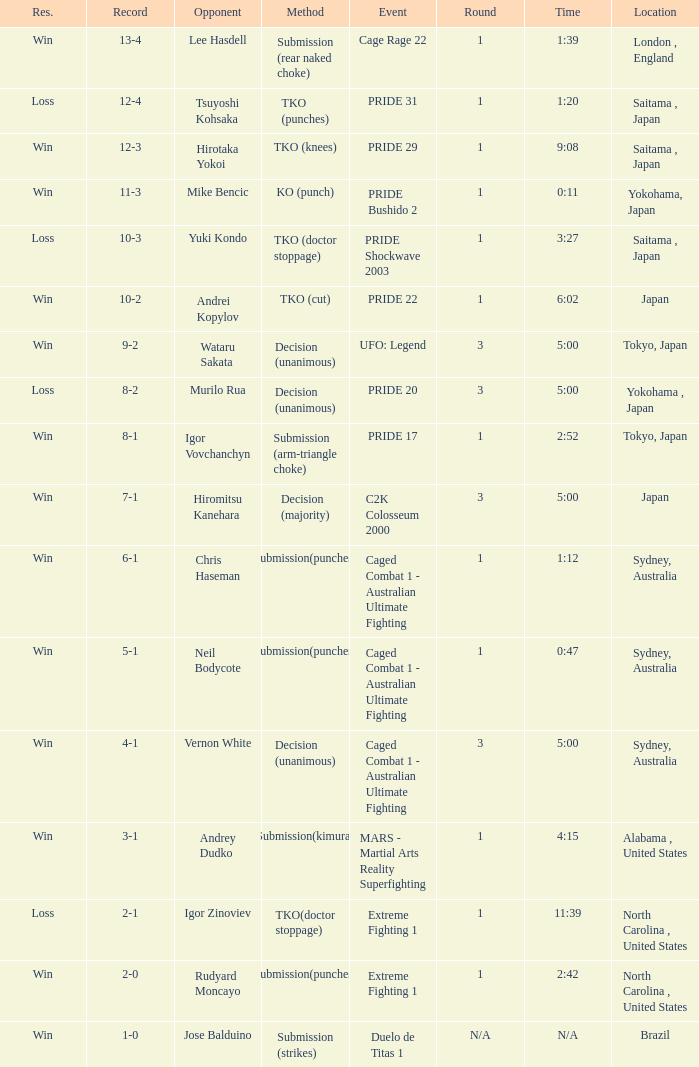Which record possesses the res of victory in the event of intense fighting 1? 2-0. 